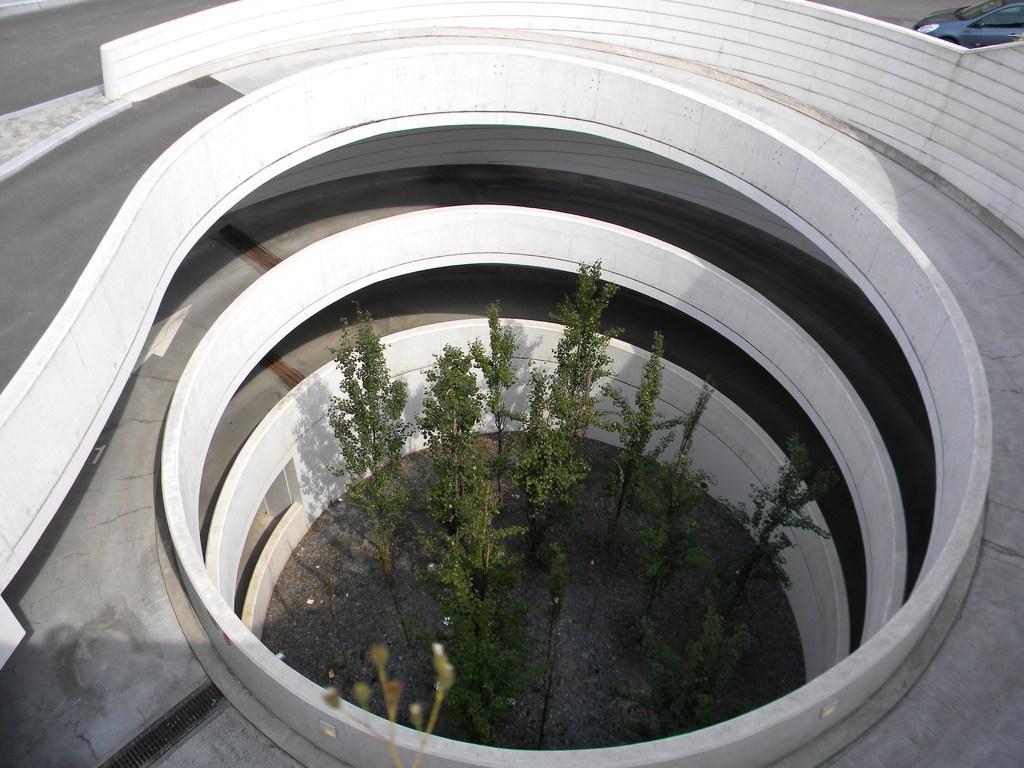Can you describe this image briefly? In this picture there are plants and it looks like a ramp. At the top right there is a vehicle. 